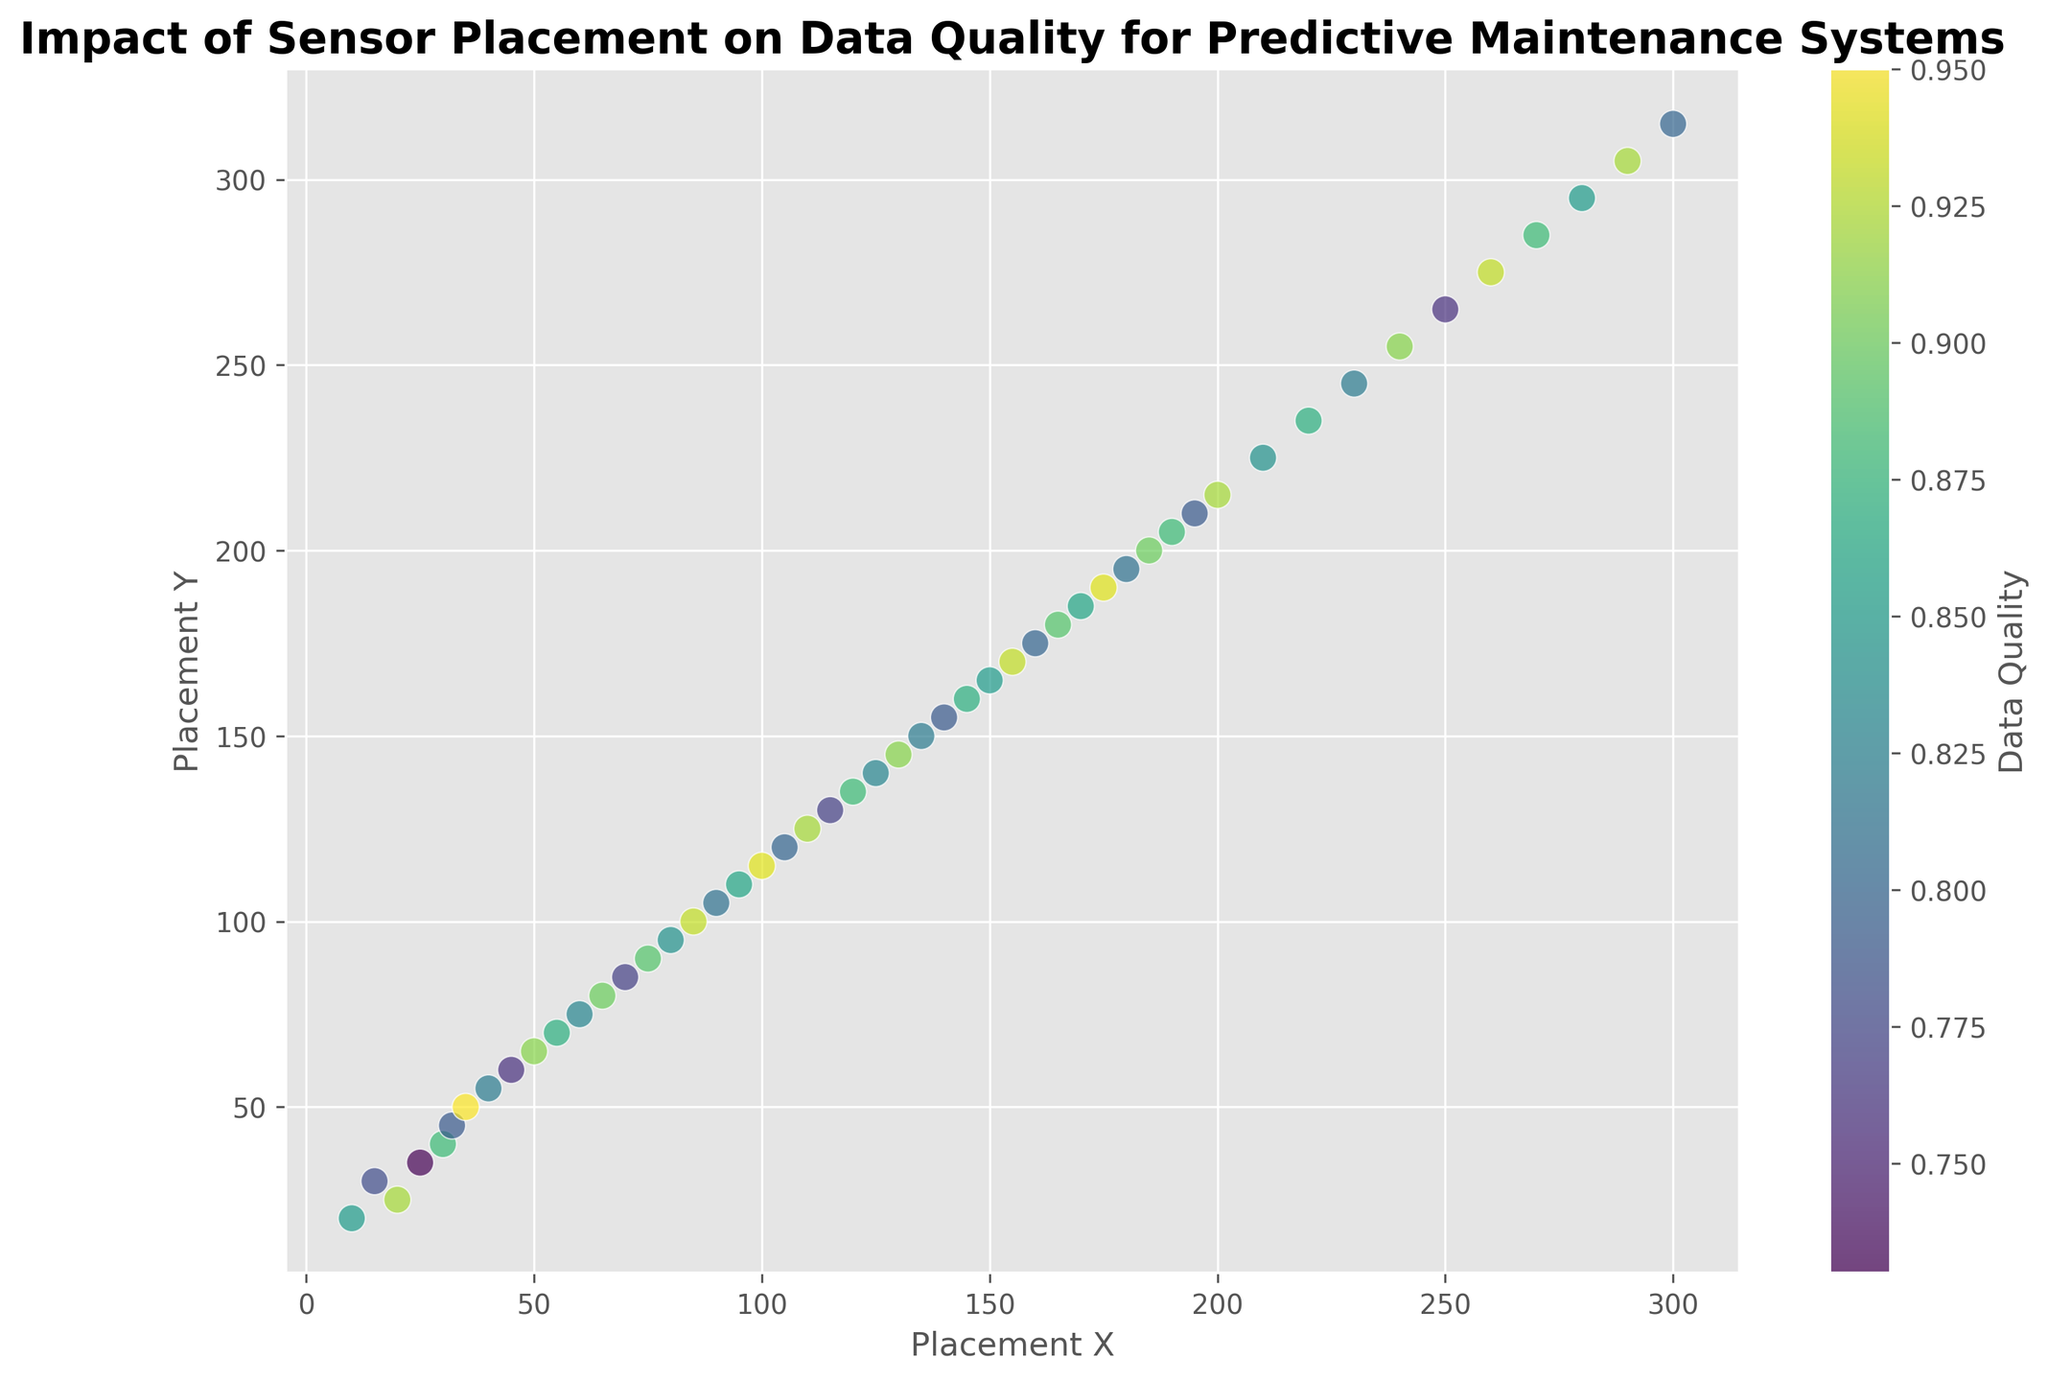Which sensor placement shows the highest data quality? The color scale (colorbar) indicates data quality, with the highest value being 0.95. Look for the placement with this highest color value. Sensor 7 has this highest value (35, 50).
Answer: (35, 50) How many sensors have a data quality above 0.90? To find this, count all the sensors whose data quality value is greater than 0.90 from the color scale and corresponding marker. The sensors meeting this criterion are 3, 7, 10, 13, 17, 20, 22, 26, 31, 35, 40, 44, 46, and 49.
Answer: 13 What is the average data quality of the sensors placed at (150, 165) and (155, 170)? Find the data quality values for these placements. Sensor 30 has a placement of (150, 165) with a quality of 0.85, and Sensor 31 has a placement of (155, 170) with a quality of 0.93. The average is calculated as (0.85 + 0.93) / 2 = 0.89
Answer: 0.89 Between (50, 65) and (55, 70), which placement has a higher data quality? Look at the data quality values for these placements. (50, 65) has a value of 0.91 and (55, 70) has a value of 0.87. So, (50, 65) has the higher value.
Answer: (50, 65) What is the median data quality of the sensors placed between (30, 40) and (70, 85) inclusive? Identify the data quality values within the range: 0.88 (30, 40), 0.79 (32, 45), 0.95 (35, 50), 0.82 (40, 55), 0.91 (50, 65), 0.87 (55, 70), 0.83 (60, 75), and 0.90 (65, 80), 0.77 (70, 85). Put these values in order: 0.77, 0.79, 0.82, 0.83, 0.87, 0.88, 0.90, 0.91, 0.95. Since there are 9 values, the median is the 5th element, or 0.87.
Answer: 0.87 